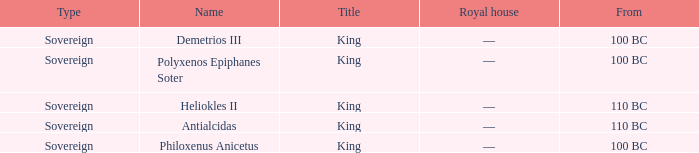When did Philoxenus Anicetus begin to hold power? 100 BC. 